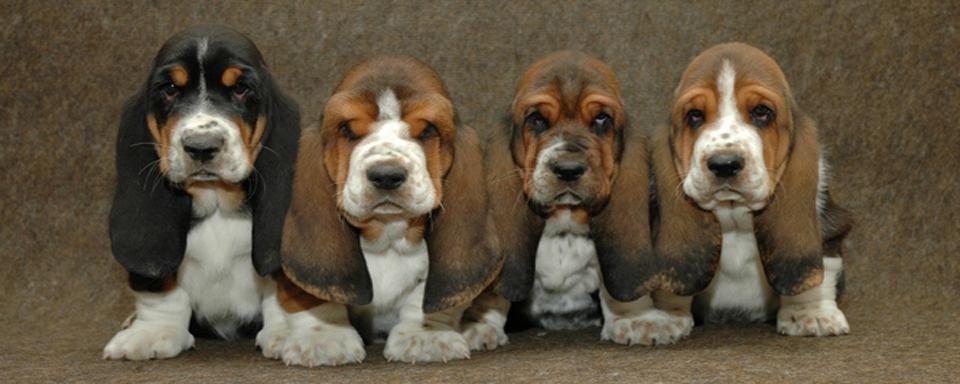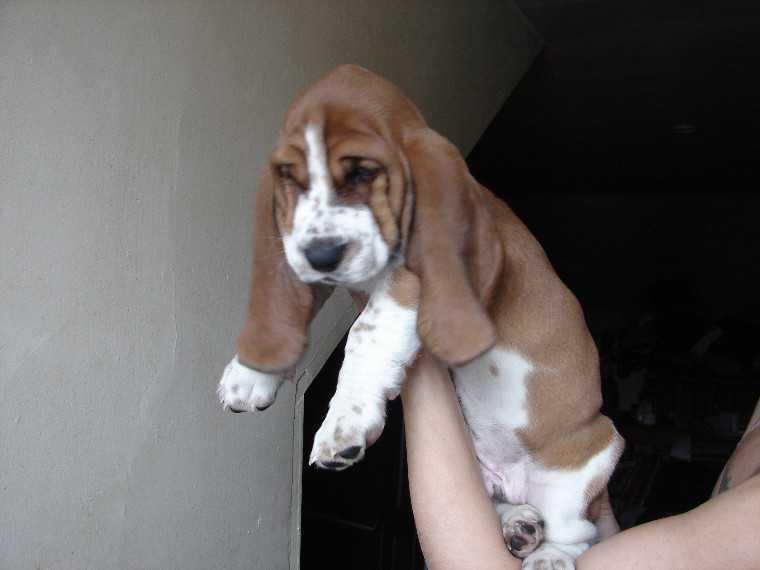The first image is the image on the left, the second image is the image on the right. Analyze the images presented: Is the assertion "There are 4 or more dogs, and one of them is being held up by a human." valid? Answer yes or no. Yes. The first image is the image on the left, the second image is the image on the right. Assess this claim about the two images: "At least three puppies are positioned directly next to each other in one photograph.". Correct or not? Answer yes or no. Yes. 